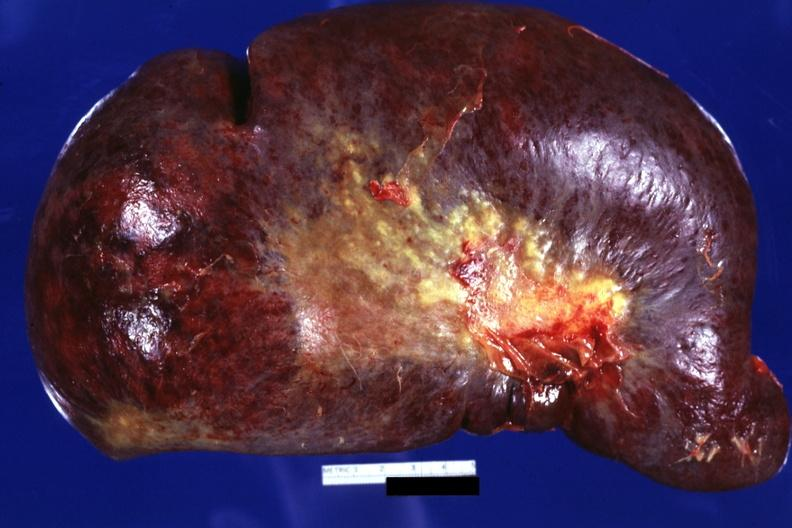s normal newborn present?
Answer the question using a single word or phrase. No 